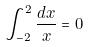Convert formula to latex. <formula><loc_0><loc_0><loc_500><loc_500>\int _ { - 2 } ^ { 2 } \frac { d x } { x } = 0</formula> 